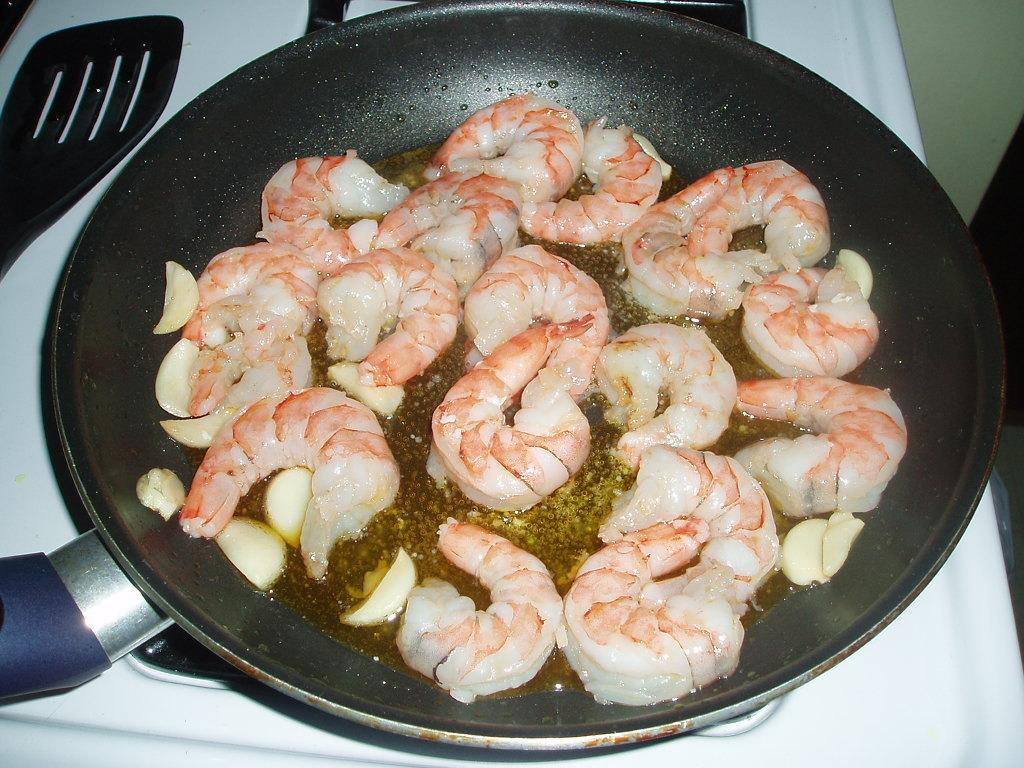What is being cooked in the pan on the stove? There is food in a pan on the stove. What utensil is visible in the image? There is a spoon visible in the image. What type of business is being conducted in the image? There is no indication of a business in the image; it primarily features food being cooked on a stove. 